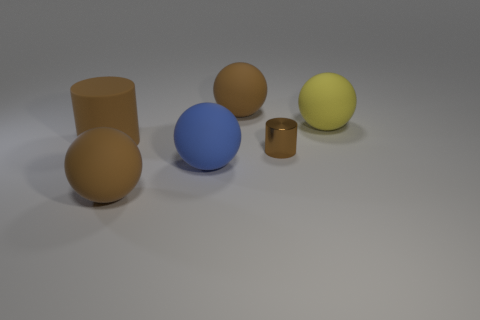What number of brown balls are behind the brown sphere behind the cylinder behind the brown metallic thing?
Ensure brevity in your answer.  0. Do the yellow matte thing and the blue rubber thing have the same shape?
Make the answer very short. Yes. Is there another brown thing of the same shape as the small brown metal thing?
Offer a terse response. Yes. There is a yellow thing that is the same size as the brown rubber cylinder; what is its shape?
Provide a short and direct response. Sphere. There is a big sphere behind the matte ball that is right of the large brown rubber ball right of the blue object; what is it made of?
Make the answer very short. Rubber. Do the yellow rubber sphere and the rubber cylinder have the same size?
Offer a very short reply. Yes. What material is the tiny cylinder?
Keep it short and to the point. Metal. There is a small thing that is the same color as the matte cylinder; what is its material?
Give a very brief answer. Metal. There is a large object to the right of the tiny brown thing; is its shape the same as the brown metal object?
Keep it short and to the point. No. What number of things are tiny things or tiny blue things?
Your answer should be very brief. 1. 